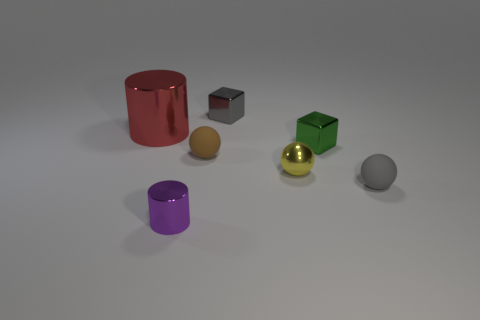Is there anything else that is the same size as the red shiny thing?
Give a very brief answer. No. What shape is the tiny rubber thing that is to the left of the tiny gray metal thing?
Offer a terse response. Sphere. How many other things are made of the same material as the small yellow thing?
Offer a terse response. 4. What material is the tiny gray block?
Your answer should be very brief. Metal. What number of small objects are either purple things or gray matte spheres?
Make the answer very short. 2. There is a large red object; what number of gray metallic things are on the left side of it?
Your answer should be compact. 0. The yellow metal object that is the same size as the gray metallic thing is what shape?
Give a very brief answer. Sphere. What number of brown objects are either metallic spheres or balls?
Provide a succinct answer. 1. What number of purple cylinders have the same size as the gray metal cube?
Provide a short and direct response. 1. What number of objects are either shiny cylinders or metal things that are in front of the red metal thing?
Ensure brevity in your answer.  4. 